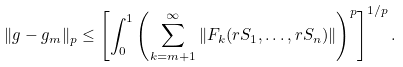Convert formula to latex. <formula><loc_0><loc_0><loc_500><loc_500>\| g - g _ { m } \| _ { p } \leq \left [ \int _ { 0 } ^ { 1 } \left ( \sum _ { k = m + 1 } ^ { \infty } \| F _ { k } ( r S _ { 1 } , \dots , r S _ { n } ) \| \right ) ^ { p } \right ] ^ { 1 / p } .</formula> 